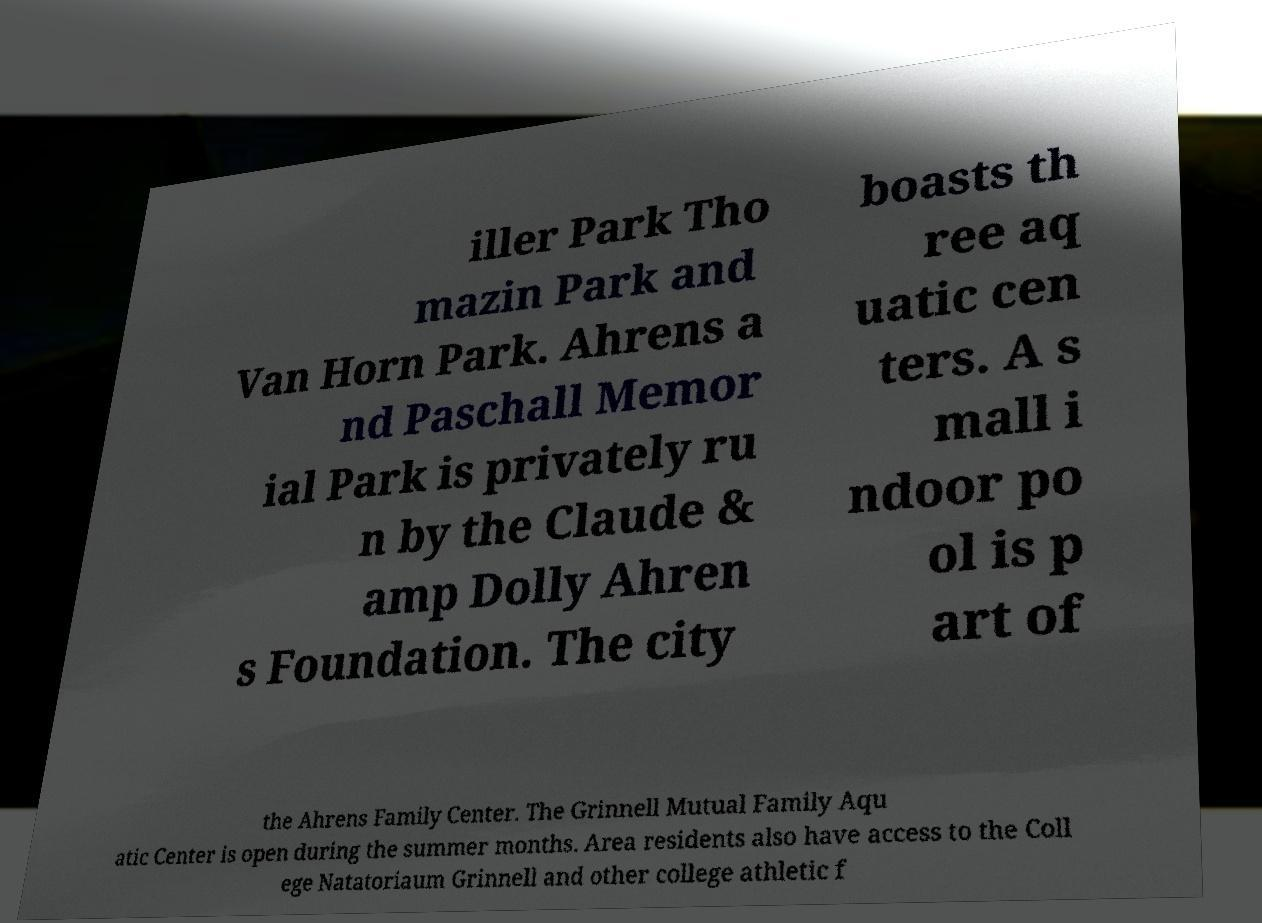For documentation purposes, I need the text within this image transcribed. Could you provide that? iller Park Tho mazin Park and Van Horn Park. Ahrens a nd Paschall Memor ial Park is privately ru n by the Claude & amp Dolly Ahren s Foundation. The city boasts th ree aq uatic cen ters. A s mall i ndoor po ol is p art of the Ahrens Family Center. The Grinnell Mutual Family Aqu atic Center is open during the summer months. Area residents also have access to the Coll ege Natatoriaum Grinnell and other college athletic f 